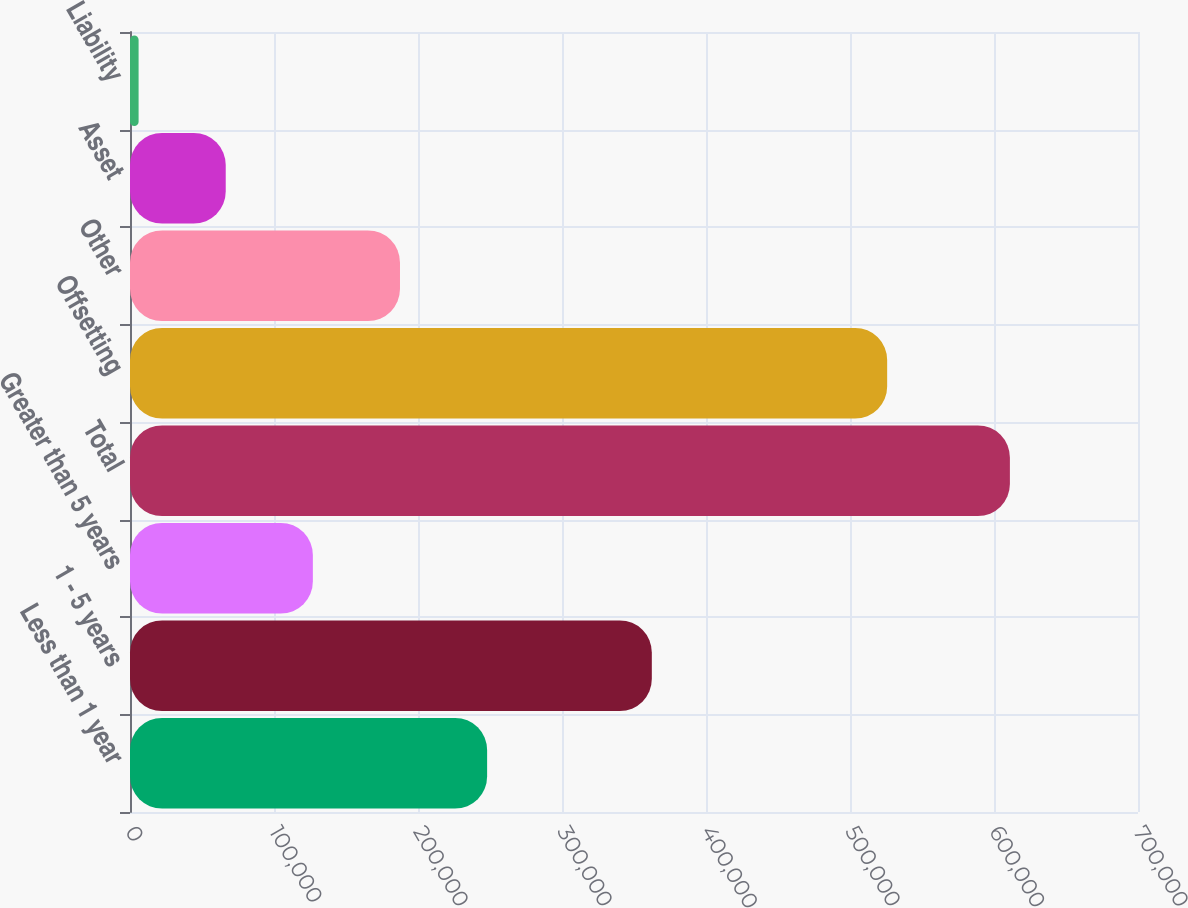Convert chart. <chart><loc_0><loc_0><loc_500><loc_500><bar_chart><fcel>Less than 1 year<fcel>1 - 5 years<fcel>Greater than 5 years<fcel>Total<fcel>Offsetting<fcel>Other<fcel>Asset<fcel>Liability<nl><fcel>247998<fcel>362373<fcel>126984<fcel>611040<fcel>525807<fcel>187491<fcel>66477<fcel>5970<nl></chart> 